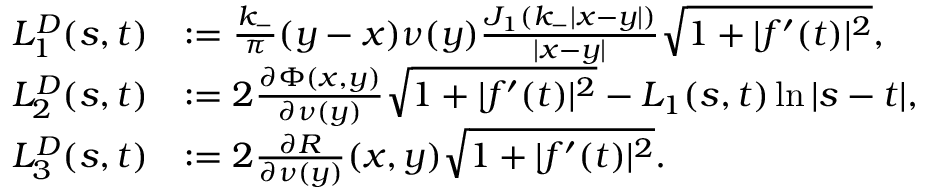Convert formula to latex. <formula><loc_0><loc_0><loc_500><loc_500>\begin{array} { r l } { L _ { 1 } ^ { D } ( s , t ) } & { \colon = \frac { k _ { - } } { \pi } ( y - x ) \nu ( y ) \frac { J _ { 1 } ( k _ { - } | x - y | ) } { | x - y | } \sqrt { 1 + | f ^ { \prime } ( t ) | ^ { 2 } } , } \\ { L _ { 2 } ^ { D } ( s , t ) } & { \colon = 2 \frac { \partial \Phi ( x , y ) } { \partial \nu ( y ) } \sqrt { 1 + | f ^ { \prime } ( t ) | ^ { 2 } } - L _ { 1 } ( s , t ) \ln | s - t | , } \\ { L _ { 3 } ^ { D } ( s , t ) } & { \colon = 2 \frac { \partial R } { \partial \nu ( y ) } ( x , y ) \sqrt { 1 + | f ^ { \prime } ( t ) | ^ { 2 } } . } \end{array}</formula> 